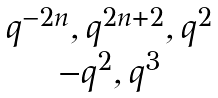<formula> <loc_0><loc_0><loc_500><loc_500>\begin{matrix} q ^ { - 2 n } , q ^ { 2 n + 2 } , q ^ { 2 } \\ - q ^ { 2 } , q ^ { 3 } \end{matrix}</formula> 